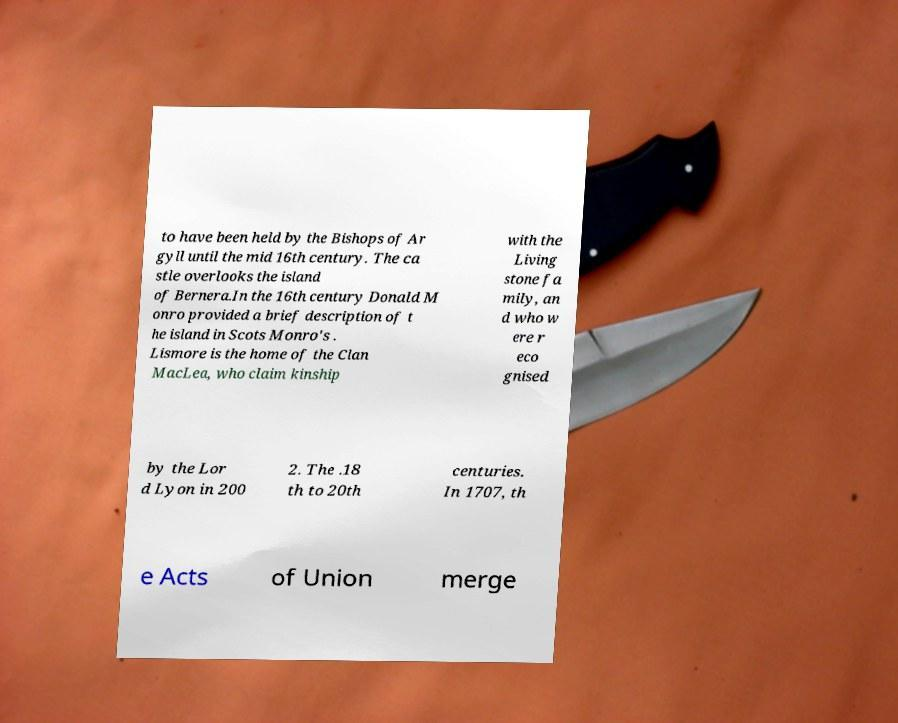What messages or text are displayed in this image? I need them in a readable, typed format. to have been held by the Bishops of Ar gyll until the mid 16th century. The ca stle overlooks the island of Bernera.In the 16th century Donald M onro provided a brief description of t he island in Scots Monro's . Lismore is the home of the Clan MacLea, who claim kinship with the Living stone fa mily, an d who w ere r eco gnised by the Lor d Lyon in 200 2. The .18 th to 20th centuries. In 1707, th e Acts of Union merge 